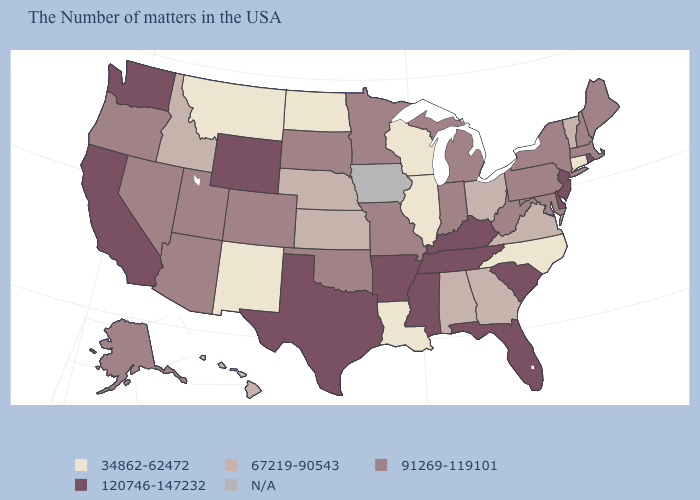What is the value of Connecticut?
Answer briefly. 34862-62472. Among the states that border Pennsylvania , which have the highest value?
Answer briefly. New Jersey, Delaware. What is the value of North Carolina?
Short answer required. 34862-62472. Among the states that border Wisconsin , does Illinois have the lowest value?
Write a very short answer. Yes. Does Pennsylvania have the lowest value in the USA?
Answer briefly. No. Name the states that have a value in the range N/A?
Write a very short answer. Iowa. Among the states that border West Virginia , which have the highest value?
Keep it brief. Kentucky. What is the lowest value in the USA?
Be succinct. 34862-62472. What is the value of Arkansas?
Write a very short answer. 120746-147232. What is the highest value in states that border Idaho?
Keep it brief. 120746-147232. Does Minnesota have the highest value in the USA?
Answer briefly. No. How many symbols are there in the legend?
Write a very short answer. 5. Which states hav the highest value in the MidWest?
Quick response, please. Michigan, Indiana, Missouri, Minnesota, South Dakota. 